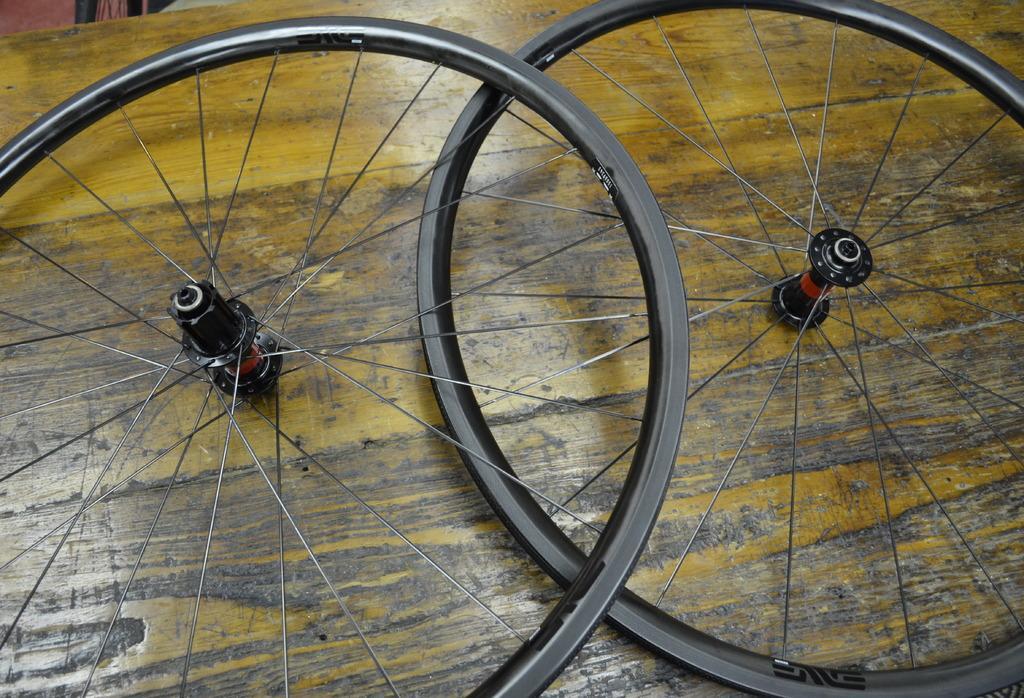How would you summarize this image in a sentence or two? In the image we can see two wheels kept on the wooden surface. 